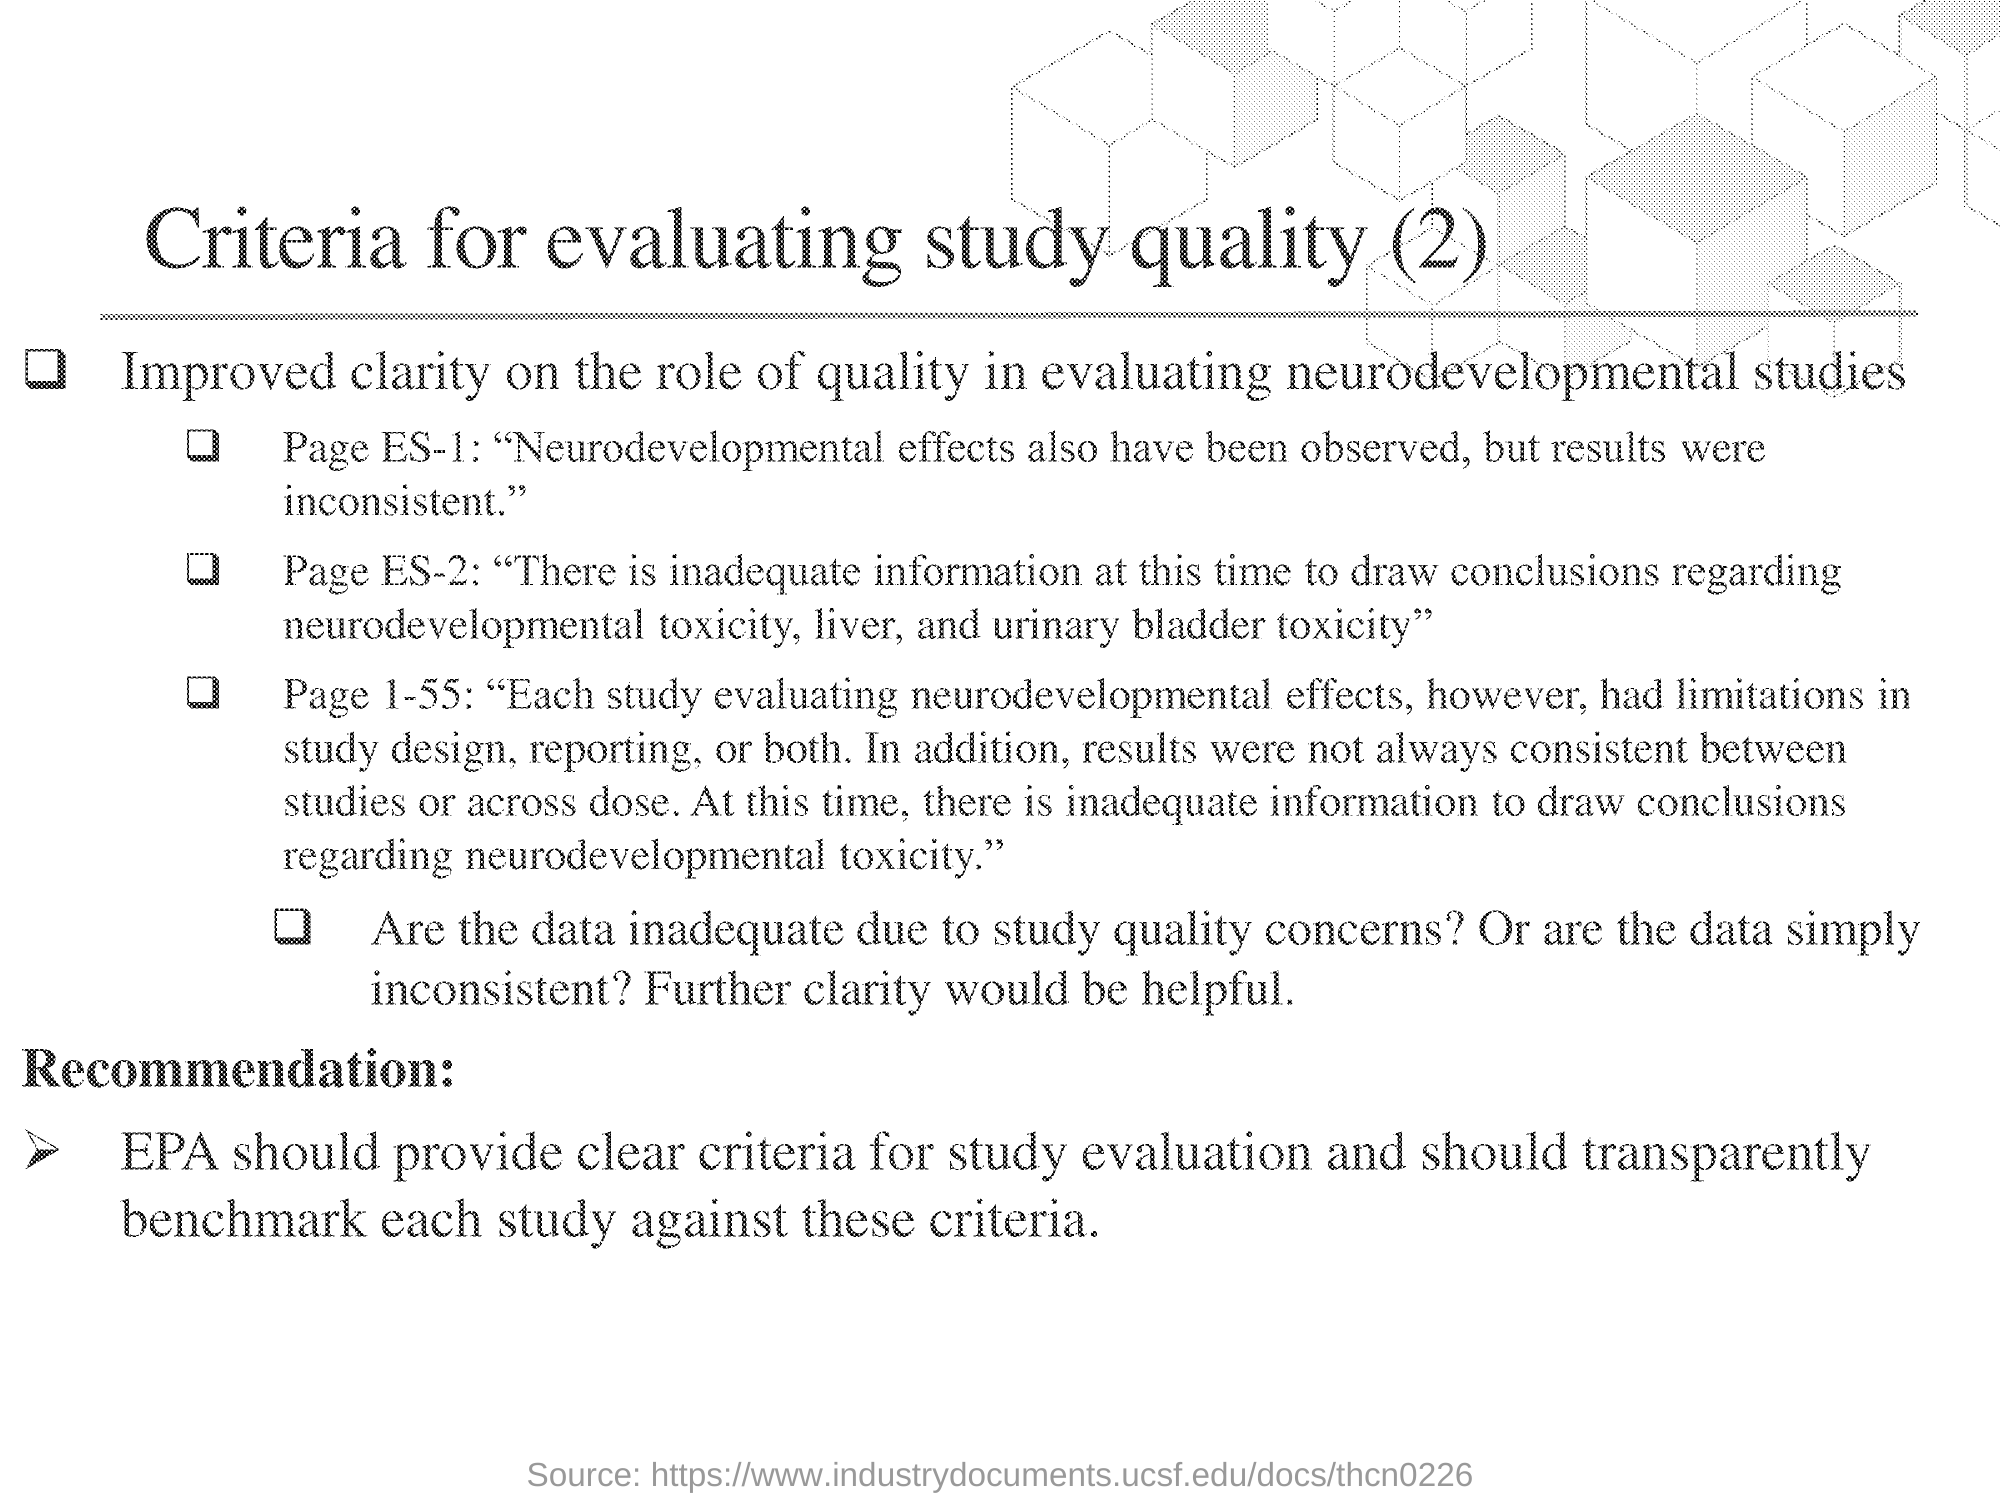What is the heading of the document?
Offer a terse response. Criteria for evaluating study quality (2). 